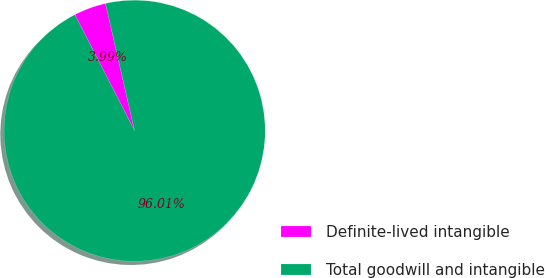Convert chart. <chart><loc_0><loc_0><loc_500><loc_500><pie_chart><fcel>Definite-lived intangible<fcel>Total goodwill and intangible<nl><fcel>3.99%<fcel>96.01%<nl></chart> 